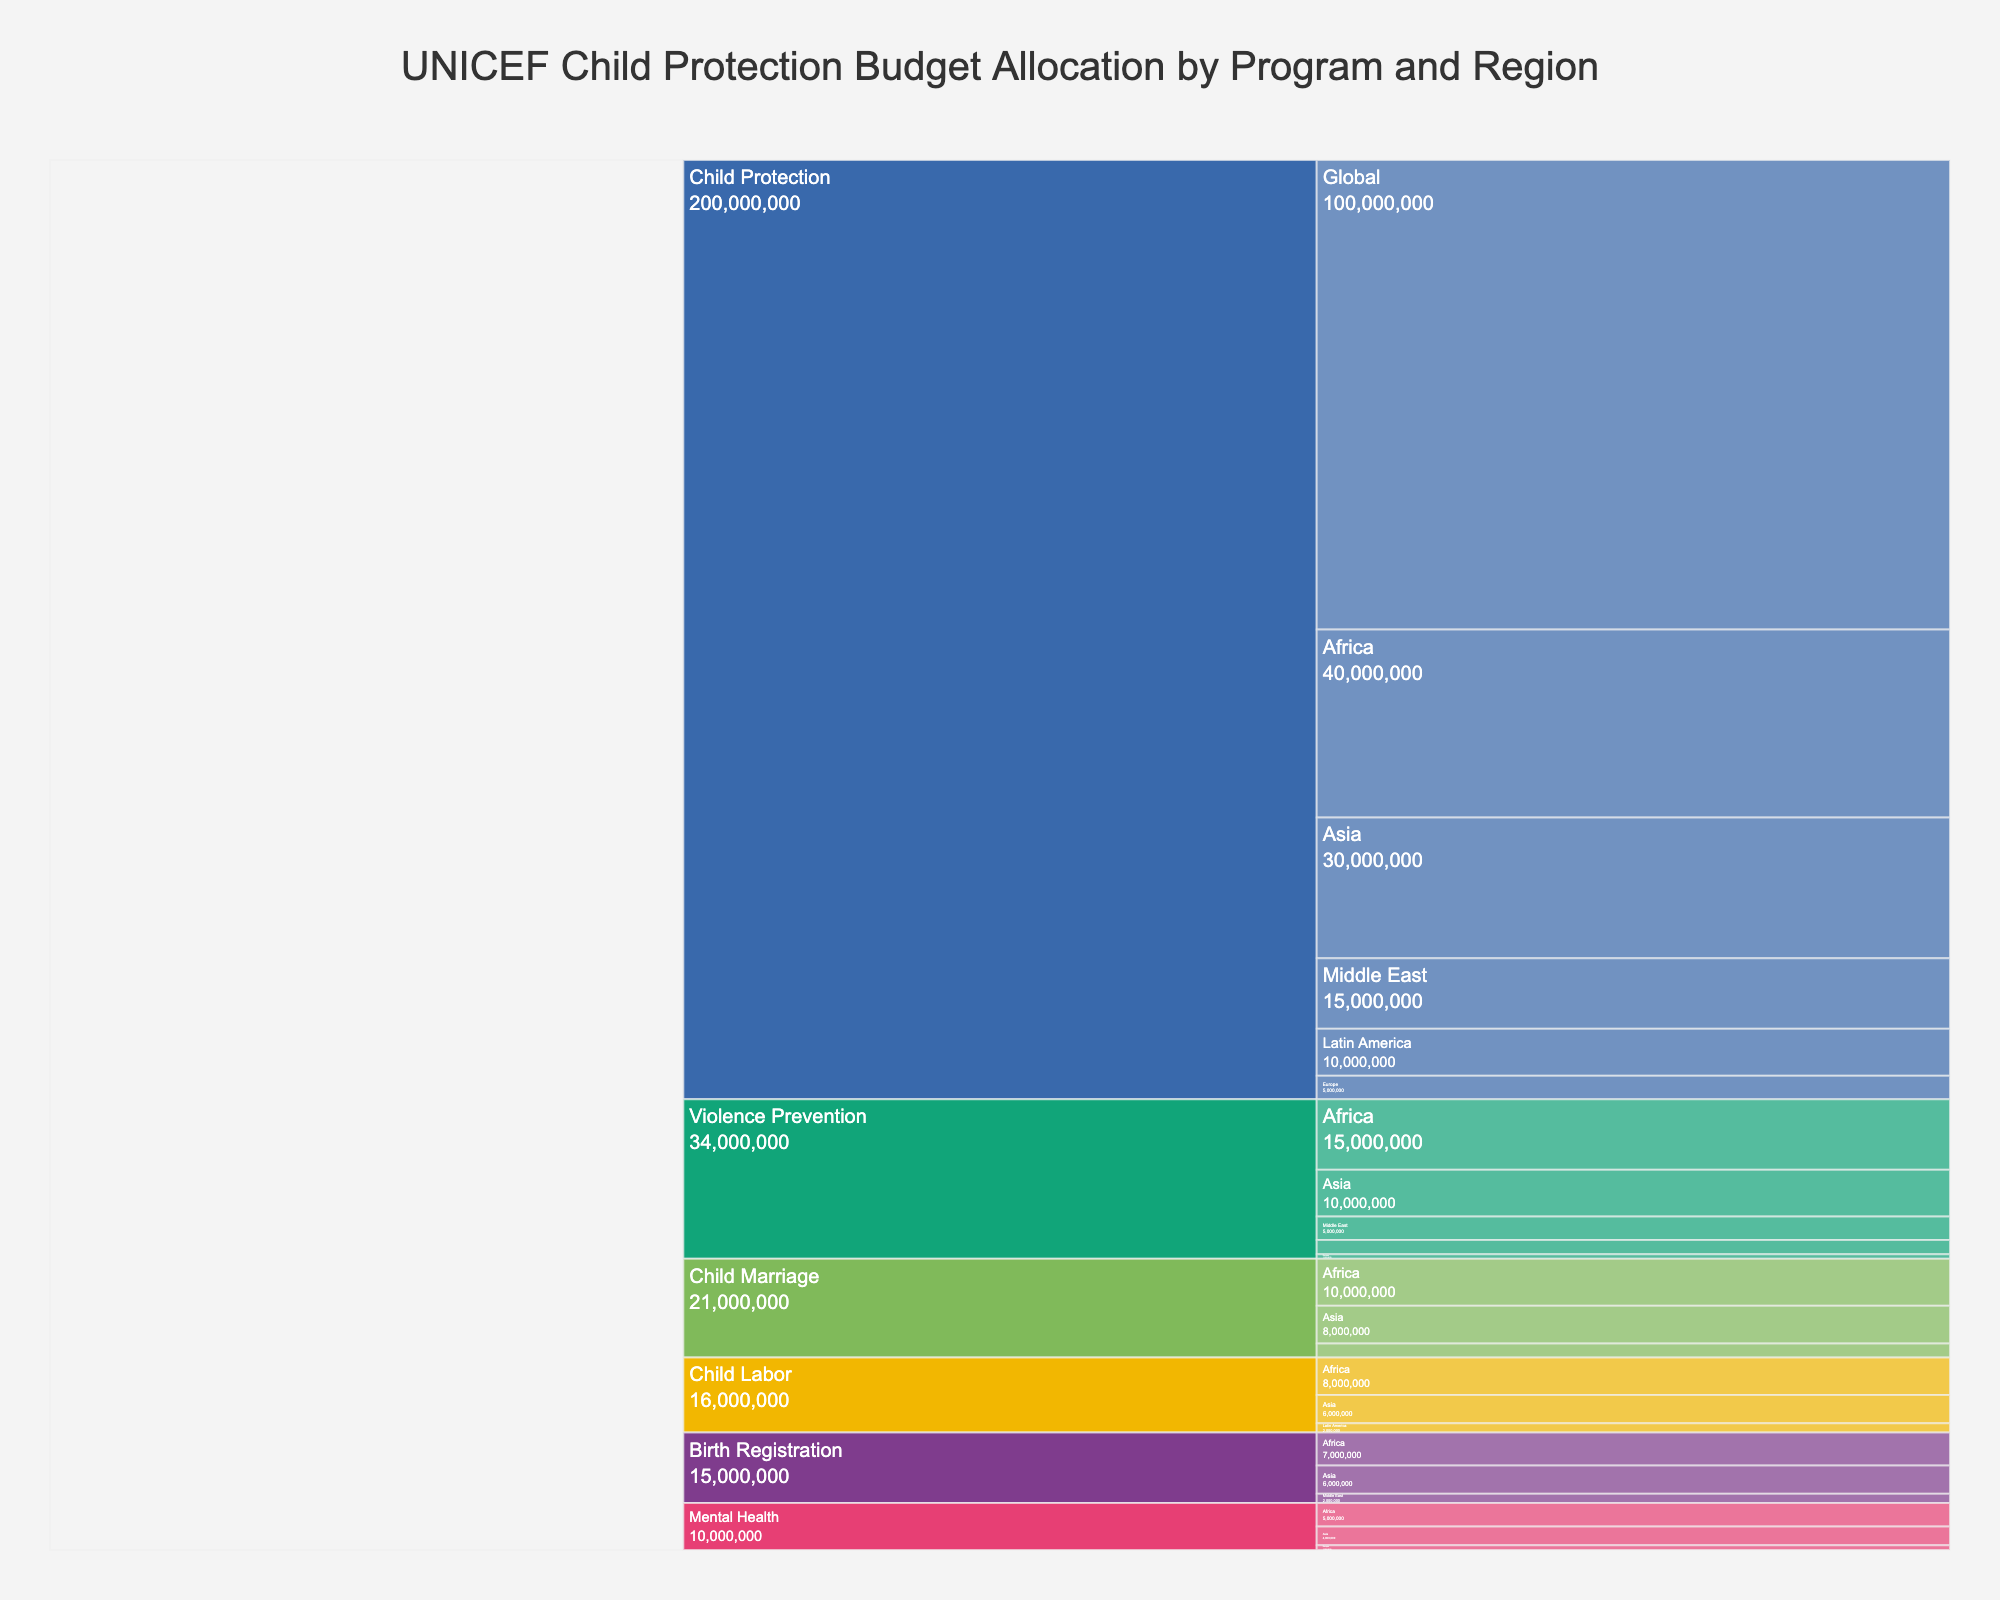What is the title of the chart? The title is displayed at the top of the chart as it contains an overview of the data being presented. The title reads: "UNICEF Child Protection Budget Allocation by Program and Region."
Answer: UNICEF Child Protection Budget Allocation by Program and Region Which region receives the highest budget allocation for 'Child Protection' programs? To find this, look at the "Child Protection" section of the icicle chart and identify the region with the largest budget allocation value.
Answer: Global What is the total budget allocated to 'Violence Prevention' programs across all regions? To calculate this, sum up the individual budget allocations for 'Violence Prevention' in each region: Africa (15000000) + Asia (10000000) + Middle East (5000000) + Latin America (3000000) + Europe (1000000).
Answer: $34,000,000 Compare the budget allocations for 'Child Marriage' programs in Africa and Asia. Which region gets more funding? In the icicle chart, identify the budget allocations for 'Child Marriage' in Africa and Asia and compare the two values.
Answer: Africa What is the total budget allocated to 'Mental Health' programs, and which region has the highest allocation in this category? Sum the budget allocations for 'Mental Health' in all regions: Africa (5000000) + Asia (4000000) + Europe (1000000). Then, identify the region with the highest single value.
Answer: $10,000,000; Africa How does the budget allocation for 'Child Labor' in Latin America compare to that in Africa? Find the budget allocations for 'Child Labor' in the specified regions and compare them: Africa ($8000000) vs. Latin America ($2000000).
Answer: Africa has a higher allocation Identify which program type receives the smallest budget allocation in Europe and state the amount. From the icicle chart, look for all program types in Europe and find the smallest budget allocation value among them.
Answer: 'Violence Prevention'; $1,000,000 What's the combined budget for 'Birth Registration' in Asia and the Middle East? Add the budget allocations for 'Birth Registration' in Asia ($6000000) and the Middle East ($2000000).
Answer: $8,000,000 Which program has a larger budget allocation in Asia: 'Child Labor' or 'Birth Registration'? Examine the values for 'Child Labor' and 'Birth Registration' in Asia from the icicle chart and compare them.
Answer: 'Child Labor' How much more budget is allocated to 'Child Protection' in Africa compared to 'Violence Prevention' in Africa? Subtract the budget allocated to 'Violence Prevention' in Africa ($15000000) from the budget allocated to 'Child Protection' in Africa ($40000000).
Answer: $25,000,000 